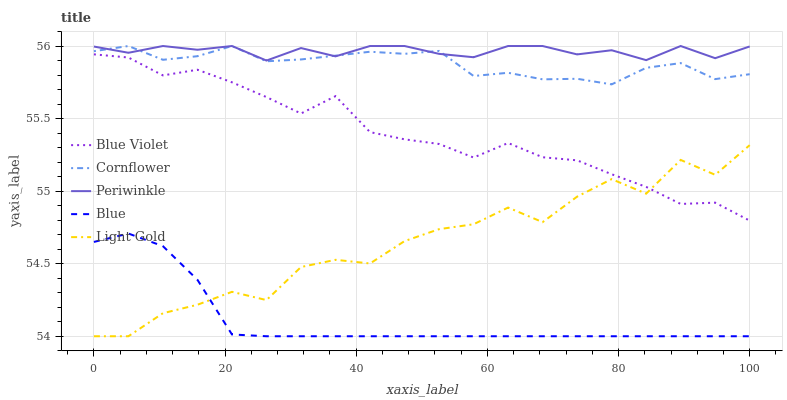Does Blue have the minimum area under the curve?
Answer yes or no. Yes. Does Periwinkle have the maximum area under the curve?
Answer yes or no. Yes. Does Cornflower have the minimum area under the curve?
Answer yes or no. No. Does Cornflower have the maximum area under the curve?
Answer yes or no. No. Is Blue the smoothest?
Answer yes or no. Yes. Is Light Gold the roughest?
Answer yes or no. Yes. Is Cornflower the smoothest?
Answer yes or no. No. Is Cornflower the roughest?
Answer yes or no. No. Does Blue have the lowest value?
Answer yes or no. Yes. Does Cornflower have the lowest value?
Answer yes or no. No. Does Periwinkle have the highest value?
Answer yes or no. Yes. Does Light Gold have the highest value?
Answer yes or no. No. Is Blue Violet less than Cornflower?
Answer yes or no. Yes. Is Periwinkle greater than Blue?
Answer yes or no. Yes. Does Periwinkle intersect Cornflower?
Answer yes or no. Yes. Is Periwinkle less than Cornflower?
Answer yes or no. No. Is Periwinkle greater than Cornflower?
Answer yes or no. No. Does Blue Violet intersect Cornflower?
Answer yes or no. No. 